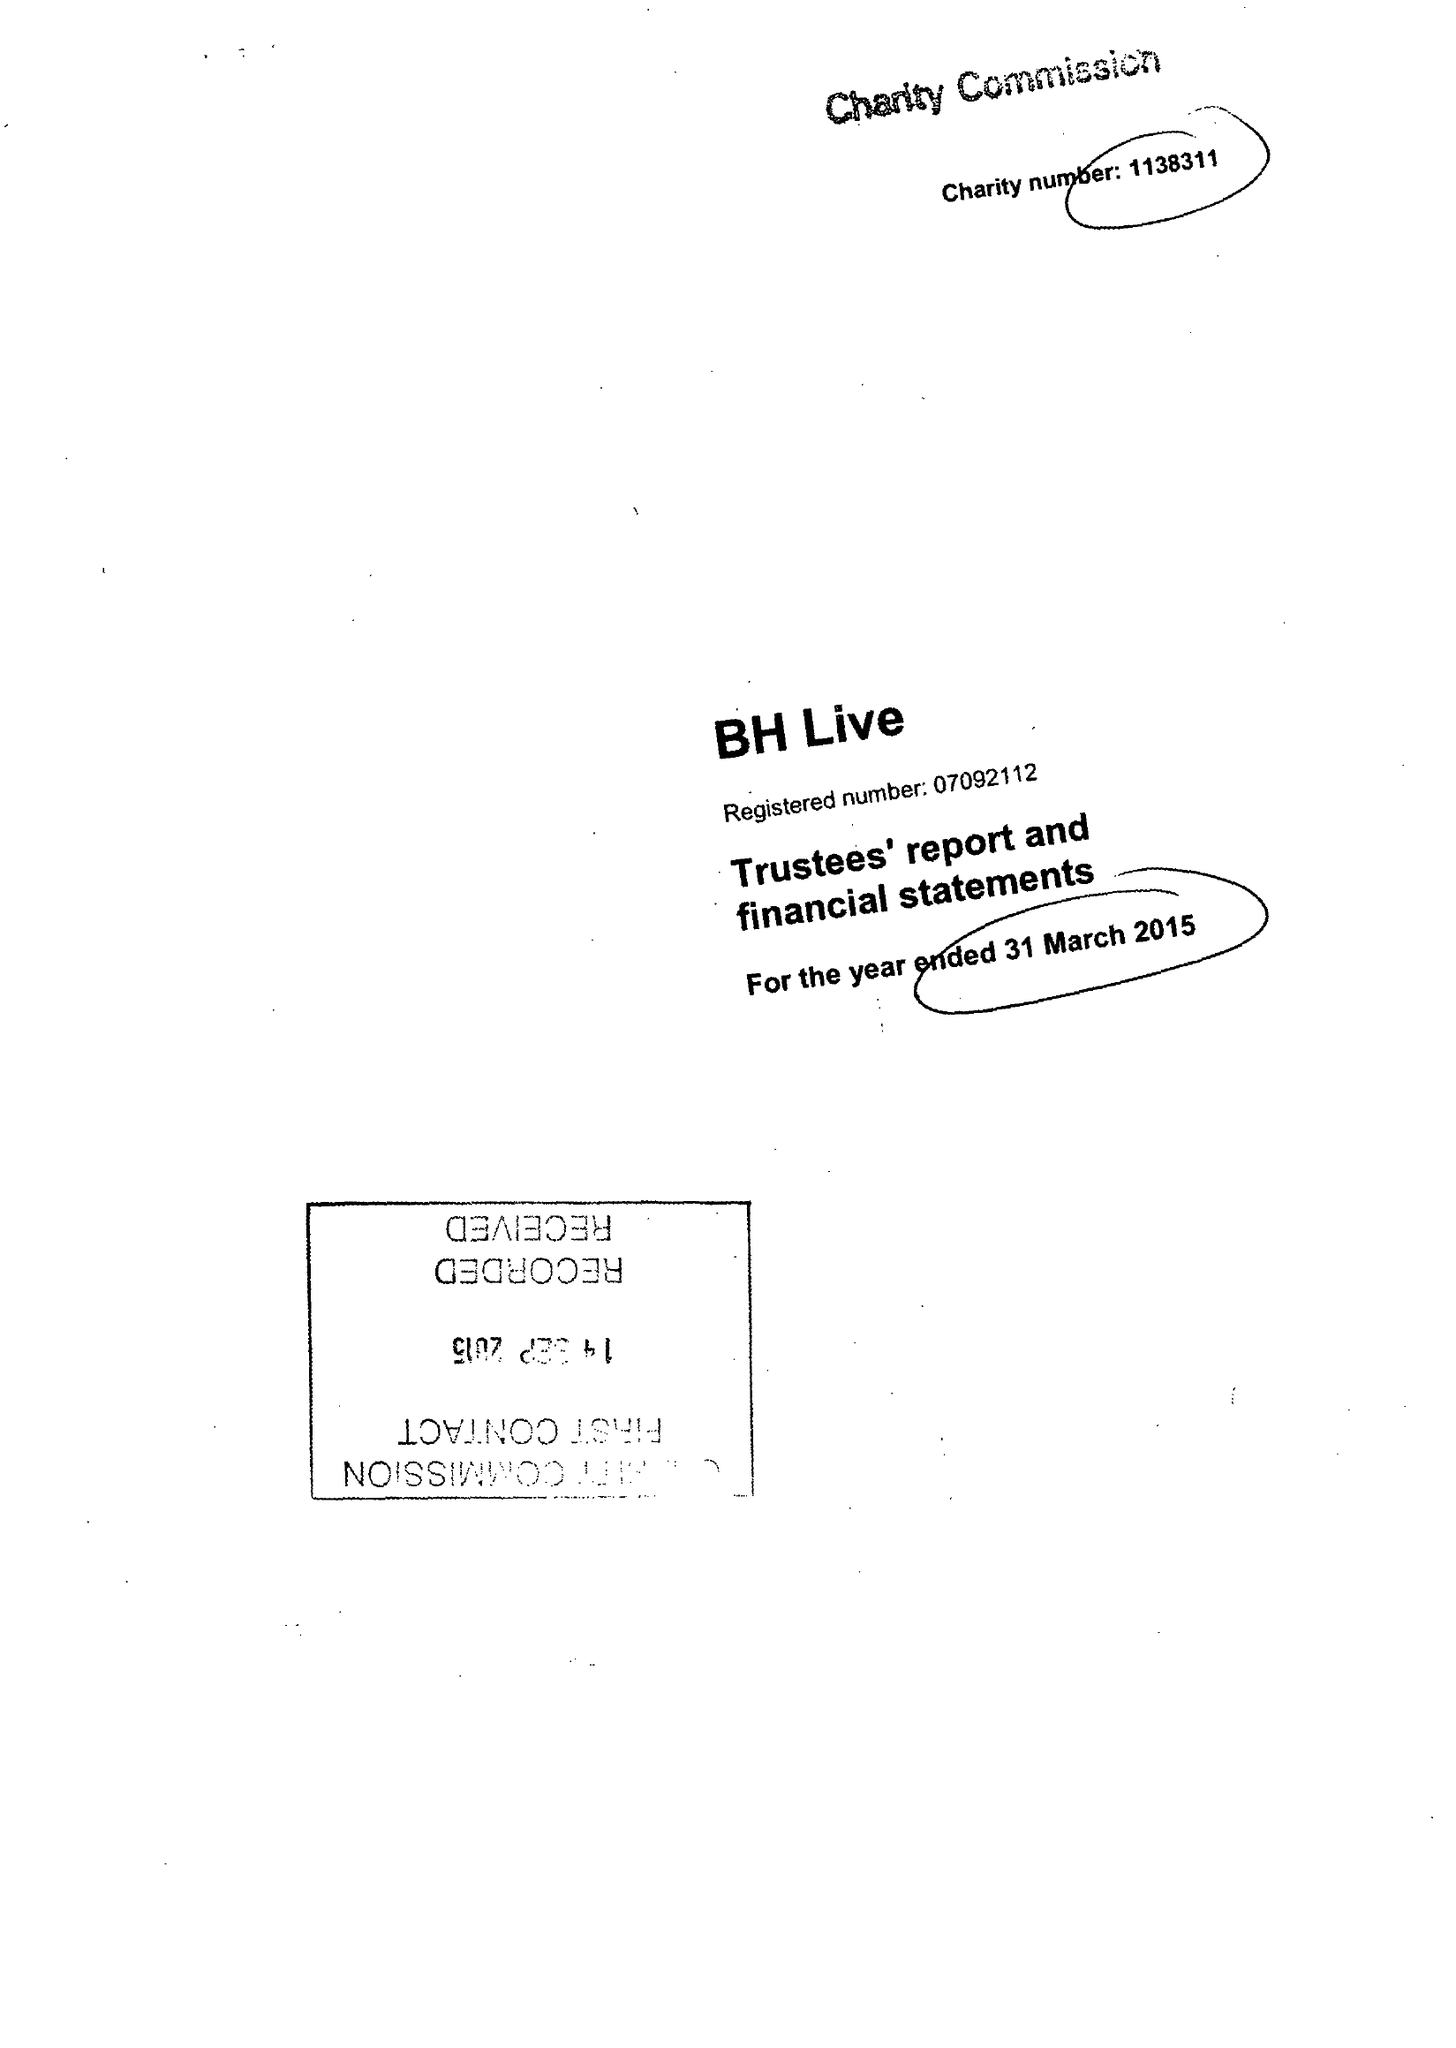What is the value for the address__street_line?
Answer the question using a single word or phrase. EXETER ROAD 